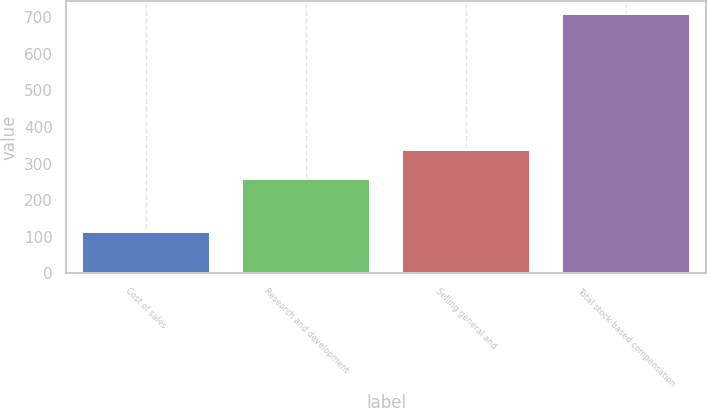<chart> <loc_0><loc_0><loc_500><loc_500><bar_chart><fcel>Cost of sales<fcel>Research and development<fcel>Selling general and<fcel>Total stock-based compensation<nl><fcel>114<fcel>258<fcel>338<fcel>710<nl></chart> 